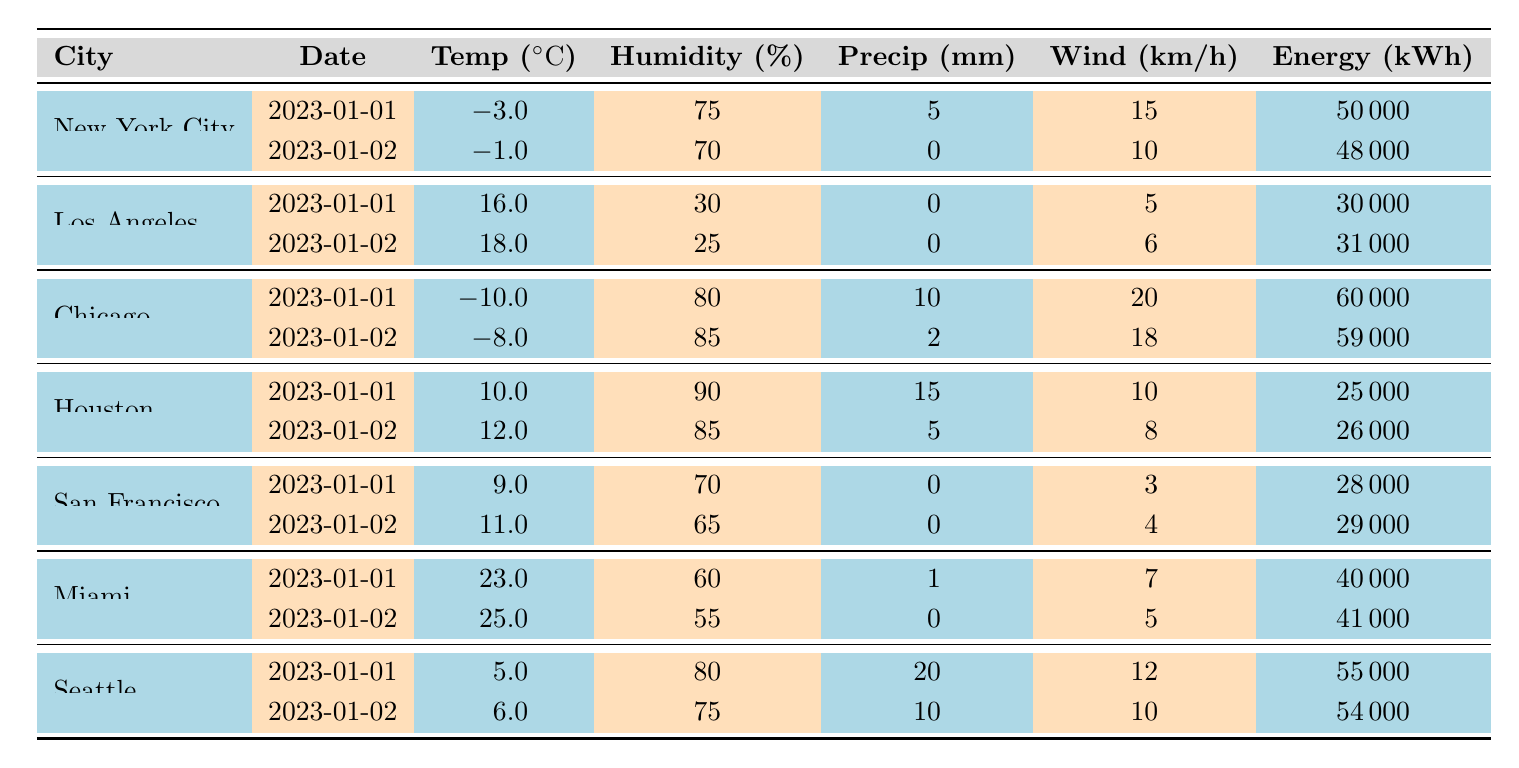What is the energy consumption in New York City on January 1? The table shows that on January 1, the energy consumption for New York City is marked at 50,000 kWh.
Answer: 50000 kWh What was the temperature in Chicago on January 2? According to the table, the temperature in Chicago on January 2 is listed as -8.0 degrees Celsius.
Answer: -8.0 °C Which city had the highest energy consumption on January 1? From the table, Chicago had the highest energy consumption on January 1 at 60,000 kWh, compared to other cities.
Answer: Chicago What is the average temperature across all cities on January 1? The temperatures on January 1 are: -3 (NYC), 16 (LA), -10 (Chicago), 10 (Houston), 9 (SF), 23 (Miami), and 5 (Seattle). Adding them gives 50. The average is 50/6 = 8.33.
Answer: 8.33 °C Did Miami experience any precipitation on January 2? The table indicates that Miami had 0 mm of precipitation on January 2, meaning it did not rain.
Answer: No What is the total energy consumption for all cities on January 2? Calculating the total energy consumption for January 2 includes: NYC 48,000 + LA 31,000 + Chicago 59,000 + Houston 26,000 + SF 29,000 + Miami 41,000 + Seattle 54,000 =  288,000 kWh.
Answer: 288000 kWh Which city had the lowest humidity percentage on January 1, and what was it? Observing the table, Los Angeles had the lowest humidity on January 1 at 30%.
Answer: 30% Was there any precipitation recorded in Los Angeles on January 2? The table notes that Los Angeles had 0 mm of precipitation on January 2, confirming no rainfall occurred.
Answer: No What is the difference in energy consumption between Chicago and Houston on January 1? Chicago's energy consumption on January 1 was 60,000 kWh, while Houston's was 25,000 kWh. The difference is 60,000 - 25,000 = 35,000 kWh.
Answer: 35000 kWh Which city had the highest wind speed recorded on January 1, and what was that speed? The highest wind speed on January 1 was noted in Chicago at 20 km/h, higher than any other city on that date.
Answer: Chicago, 20 km/h 